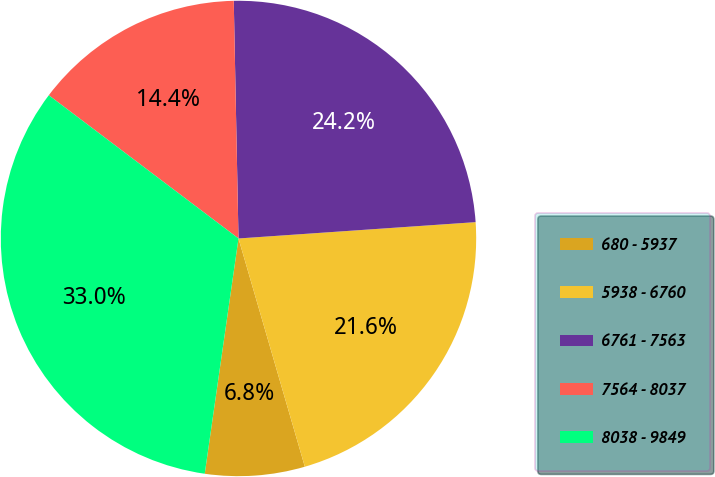Convert chart to OTSL. <chart><loc_0><loc_0><loc_500><loc_500><pie_chart><fcel>680 - 5937<fcel>5938 - 6760<fcel>6761 - 7563<fcel>7564 - 8037<fcel>8038 - 9849<nl><fcel>6.77%<fcel>21.59%<fcel>24.22%<fcel>14.39%<fcel>33.02%<nl></chart> 